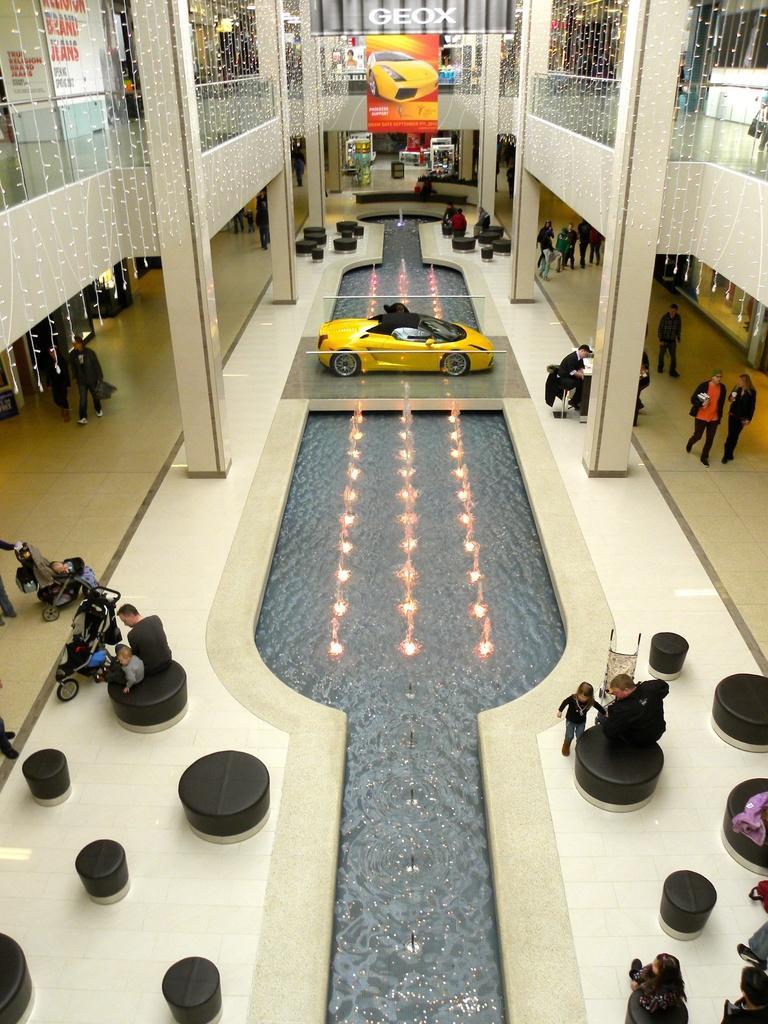In one or two sentences, can you explain what this image depicts? This is car, this is building and banner, here some people are sitting and some people are walking, these are lights. 